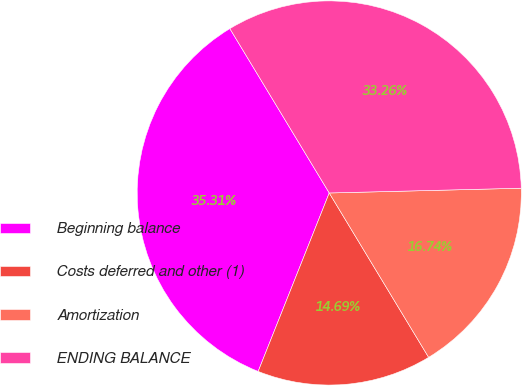Convert chart to OTSL. <chart><loc_0><loc_0><loc_500><loc_500><pie_chart><fcel>Beginning balance<fcel>Costs deferred and other (1)<fcel>Amortization<fcel>ENDING BALANCE<nl><fcel>35.31%<fcel>14.69%<fcel>16.74%<fcel>33.26%<nl></chart> 